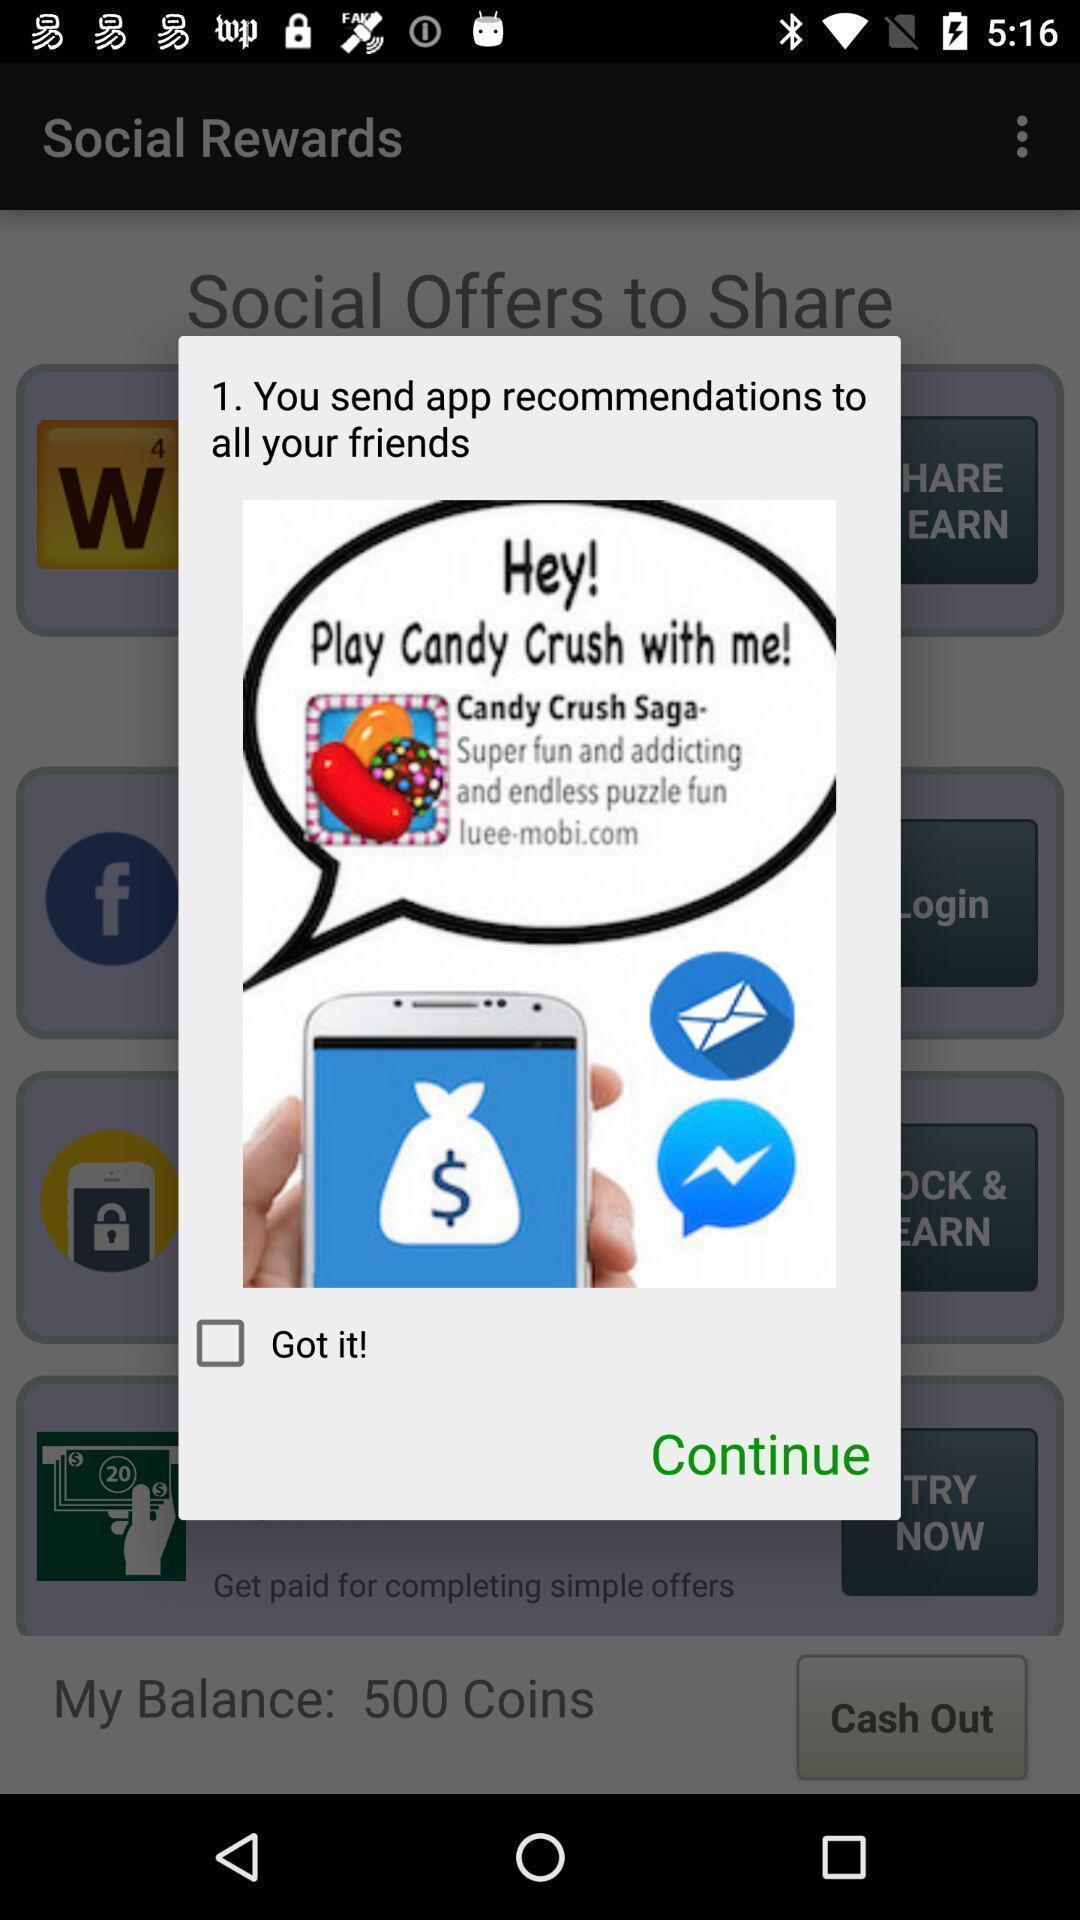Describe the visual elements of this screenshot. Pop-up displaying notification regarding app recommendations sent to friends. 